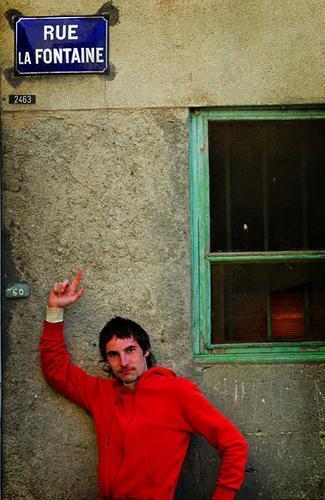How many people are in the picture?
Give a very brief answer. 1. How many zebras are in the picture?
Give a very brief answer. 0. 